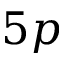<formula> <loc_0><loc_0><loc_500><loc_500>5 p</formula> 